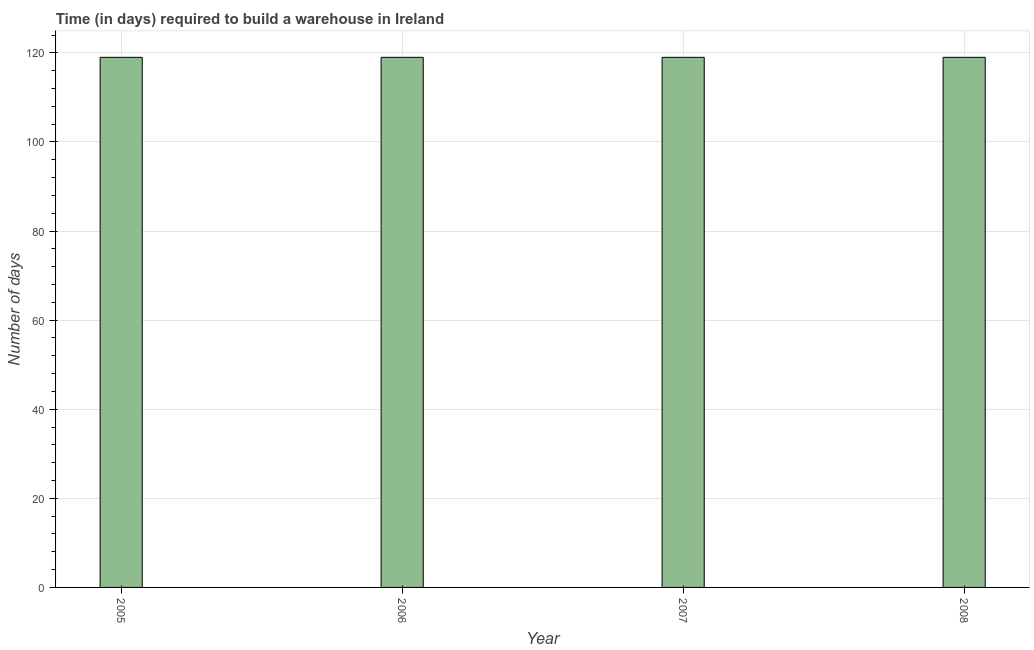What is the title of the graph?
Keep it short and to the point. Time (in days) required to build a warehouse in Ireland. What is the label or title of the X-axis?
Give a very brief answer. Year. What is the label or title of the Y-axis?
Your answer should be compact. Number of days. What is the time required to build a warehouse in 2007?
Your answer should be compact. 119. Across all years, what is the maximum time required to build a warehouse?
Ensure brevity in your answer.  119. Across all years, what is the minimum time required to build a warehouse?
Offer a very short reply. 119. In which year was the time required to build a warehouse minimum?
Give a very brief answer. 2005. What is the sum of the time required to build a warehouse?
Provide a succinct answer. 476. What is the average time required to build a warehouse per year?
Give a very brief answer. 119. What is the median time required to build a warehouse?
Your response must be concise. 119. What is the ratio of the time required to build a warehouse in 2006 to that in 2007?
Your response must be concise. 1. What is the difference between the highest and the second highest time required to build a warehouse?
Your answer should be very brief. 0. How many years are there in the graph?
Offer a terse response. 4. What is the Number of days of 2005?
Provide a succinct answer. 119. What is the Number of days of 2006?
Your response must be concise. 119. What is the Number of days in 2007?
Your answer should be compact. 119. What is the Number of days in 2008?
Offer a terse response. 119. What is the difference between the Number of days in 2005 and 2007?
Your answer should be very brief. 0. What is the difference between the Number of days in 2005 and 2008?
Your response must be concise. 0. What is the difference between the Number of days in 2006 and 2007?
Your response must be concise. 0. What is the difference between the Number of days in 2006 and 2008?
Your response must be concise. 0. What is the ratio of the Number of days in 2005 to that in 2006?
Offer a terse response. 1. What is the ratio of the Number of days in 2005 to that in 2007?
Make the answer very short. 1. What is the ratio of the Number of days in 2006 to that in 2008?
Offer a terse response. 1. 